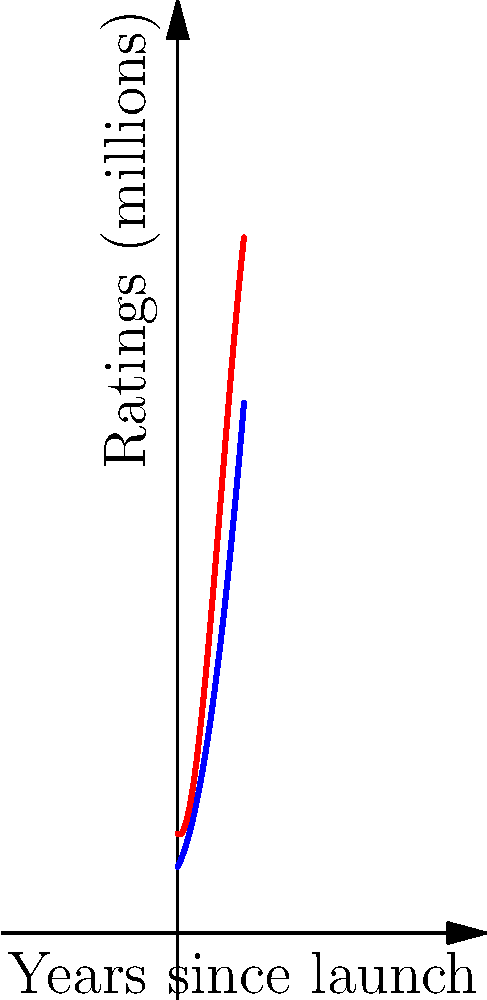As a pioneer in the television industry, you're analyzing the growth of two TV stations over their first decade. The graph shows the ratings (in millions of viewers) for Station A and Station B over 10 years since their launch. Station A's ratings follow a quadratic function, while Station B's follow a cubic function. At what point in time do the two stations have equal ratings, and what is that rating? To solve this problem, we need to follow these steps:

1) Identify the functions for each station:
   Station A: $f_1(x) = 0.5x^2 + 2x + 10$
   Station B: $f_2(x) = -0.1x^3 + 2x^2 - x + 15$

2) To find where the ratings are equal, we set the functions equal to each other:
   $0.5x^2 + 2x + 10 = -0.1x^3 + 2x^2 - x + 15$

3) Rearrange the equation:
   $0.1x^3 + 1.5x^2 - 3x - 5 = 0$

4) This is a cubic equation. It can be solved using the cubic formula or by factoring. In this case, we can factor it:
   $0.1(x^3 + 15x^2 - 30x - 50) = 0$
   $0.1(x + 10)(x^2 + 5x - 5) = 0$
   $0.1(x + 10)(x + 5)(x - 1) = 0$

5) The solutions are $x = -10$, $x = -5$, and $x = 1$. Since we're dealing with years since launch, only the positive solution is relevant.

6) Therefore, the stations have equal ratings after 1 year.

7) To find the rating at this point, we can plug $x = 1$ into either function:
   $f_1(1) = 0.5(1)^2 + 2(1) + 10 = 12.5$ million viewers

Therefore, after 1 year, both stations have a rating of 12.5 million viewers.
Answer: After 1 year, with 12.5 million viewers. 